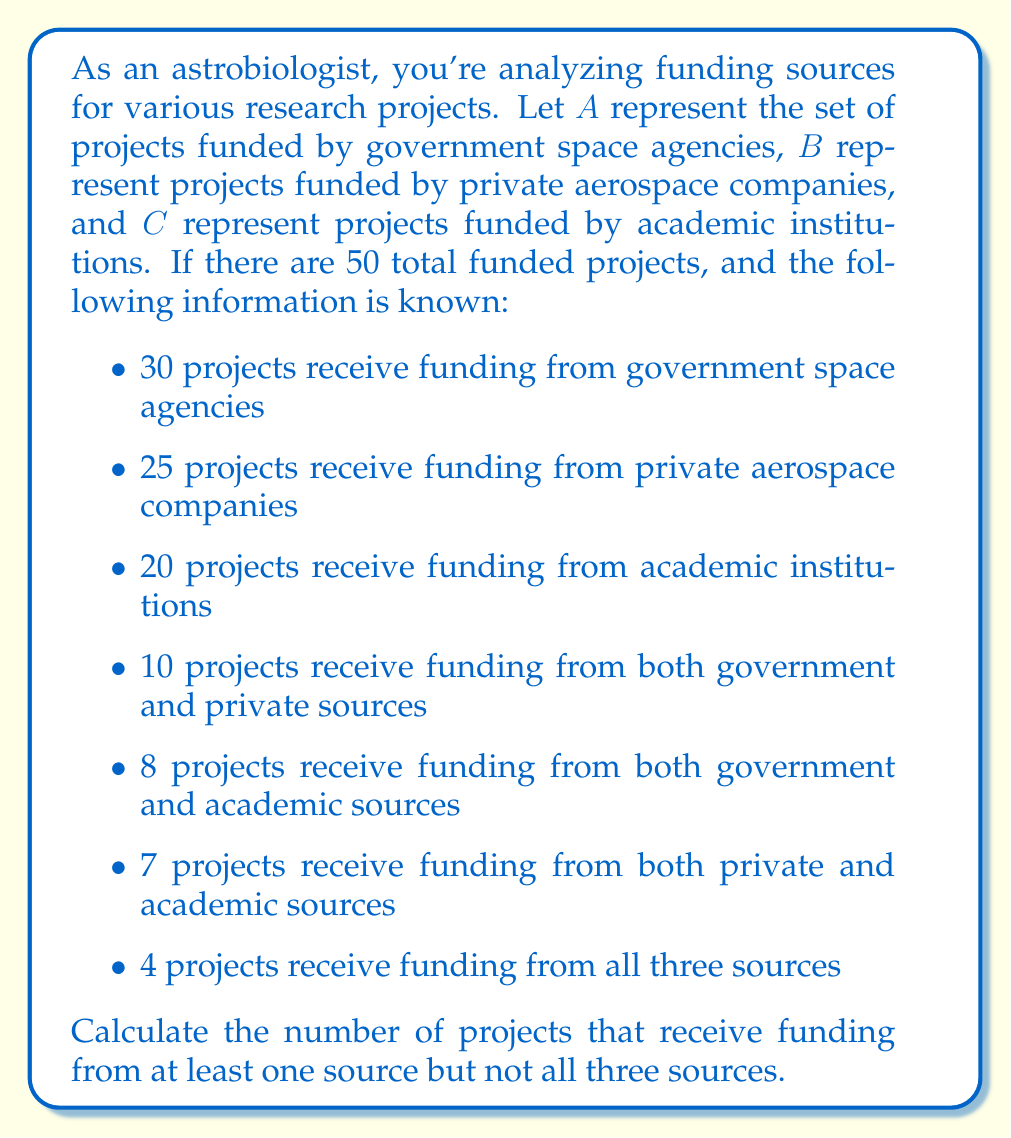Give your solution to this math problem. Let's approach this step-by-step using set theory:

1) First, we need to find $|A \cup B \cup C|$, which represents the total number of projects funded by at least one source.

2) We can use the inclusion-exclusion principle:

   $$|A \cup B \cup C| = |A| + |B| + |C| - |A \cap B| - |A \cap C| - |B \cap C| + |A \cap B \cap C|$$

3) We know:
   $|A| = 30$, $|B| = 25$, $|C| = 20$
   $|A \cap B| = 10$, $|A \cap C| = 8$, $|B \cap C| = 7$
   $|A \cap B \cap C| = 4$

4) Substituting these values:

   $$|A \cup B \cup C| = 30 + 25 + 20 - 10 - 8 - 7 + 4 = 54$$

5) However, this is more than the total number of projects (50). This means that $|A \cup B \cup C| = 50$, i.e., all projects receive funding from at least one source.

6) Now, we need to subtract the number of projects funded by all three sources from the total:

   $$\text{Projects funded by at least one but not all sources} = 50 - 4 = 46$$

Therefore, 46 projects receive funding from at least one source but not all three sources.
Answer: 46 projects 